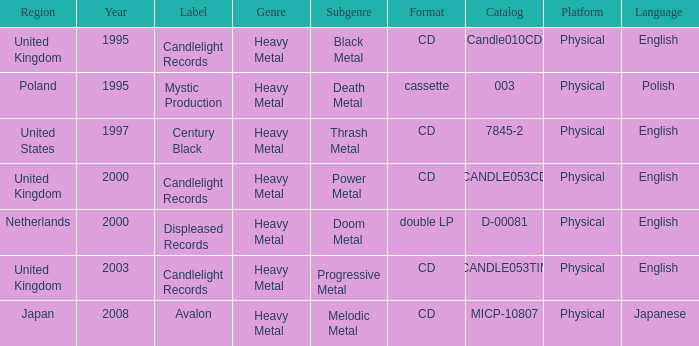What year did Japan form a label? 2008.0. 